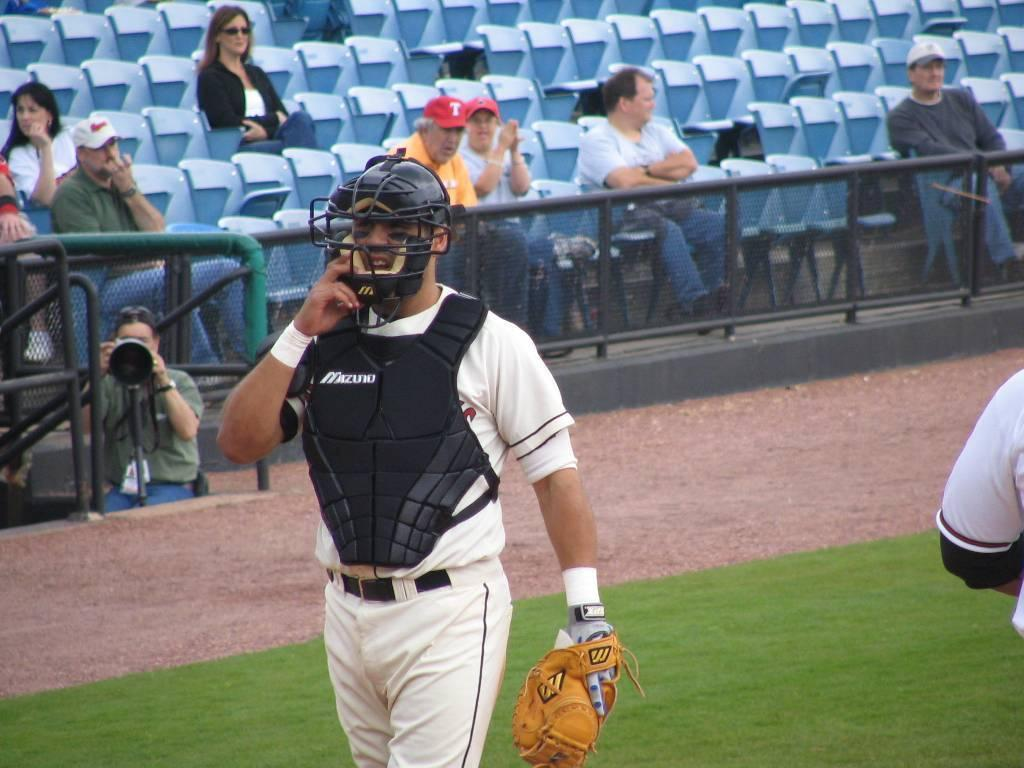<image>
Summarize the visual content of the image. a catcher with Mizuno written on their chest protector 